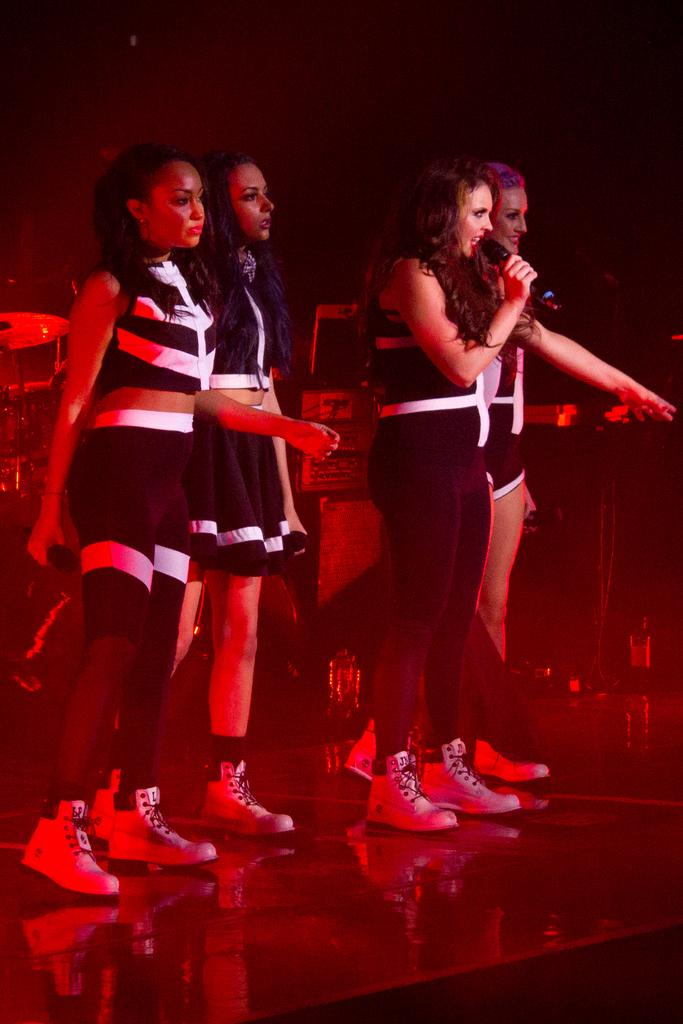How many people are in the image? There are persons standing in the image. What are the people wearing? The persons are wearing clothes. What objects are the people holding in their hands? Two persons are holding microphones in their hands. What type of zinc can be seen in the image? There is no zinc present in the image. Can you see a cat in the image? There is no cat present in the image. 